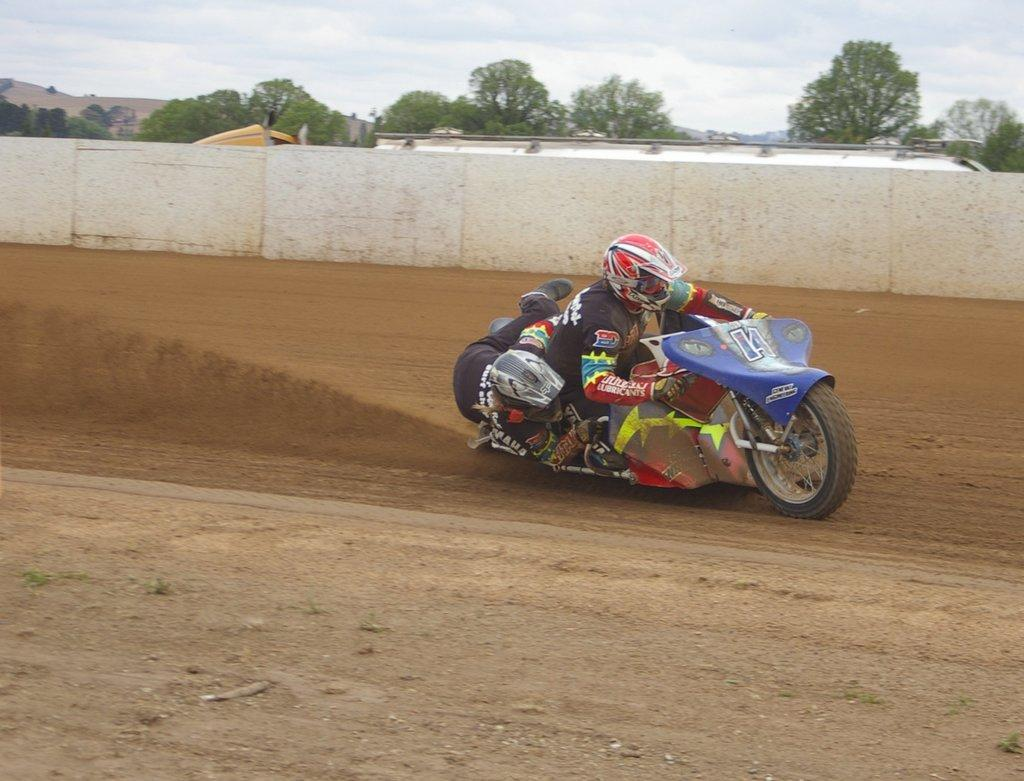What is the main subject of the image? There is a person riding a bike in the image. What can be seen in the background of the image? There is a wall, a shed, and trees in the background of the image. What is visible at the bottom of the image? The ground is visible at the bottom of the image. What type of doll is sitting on the wall in the image? There is no doll present in the image; it features a person riding a bike with a background of a wall, shed, and trees. 